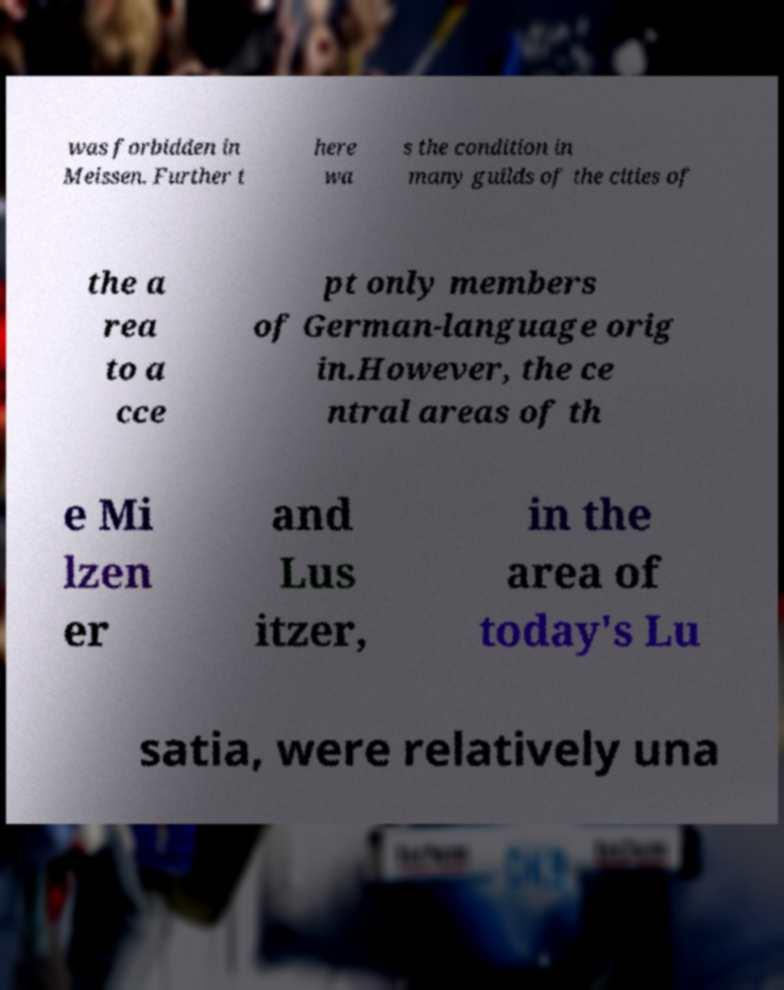Please identify and transcribe the text found in this image. was forbidden in Meissen. Further t here wa s the condition in many guilds of the cities of the a rea to a cce pt only members of German-language orig in.However, the ce ntral areas of th e Mi lzen er and Lus itzer, in the area of today's Lu satia, were relatively una 